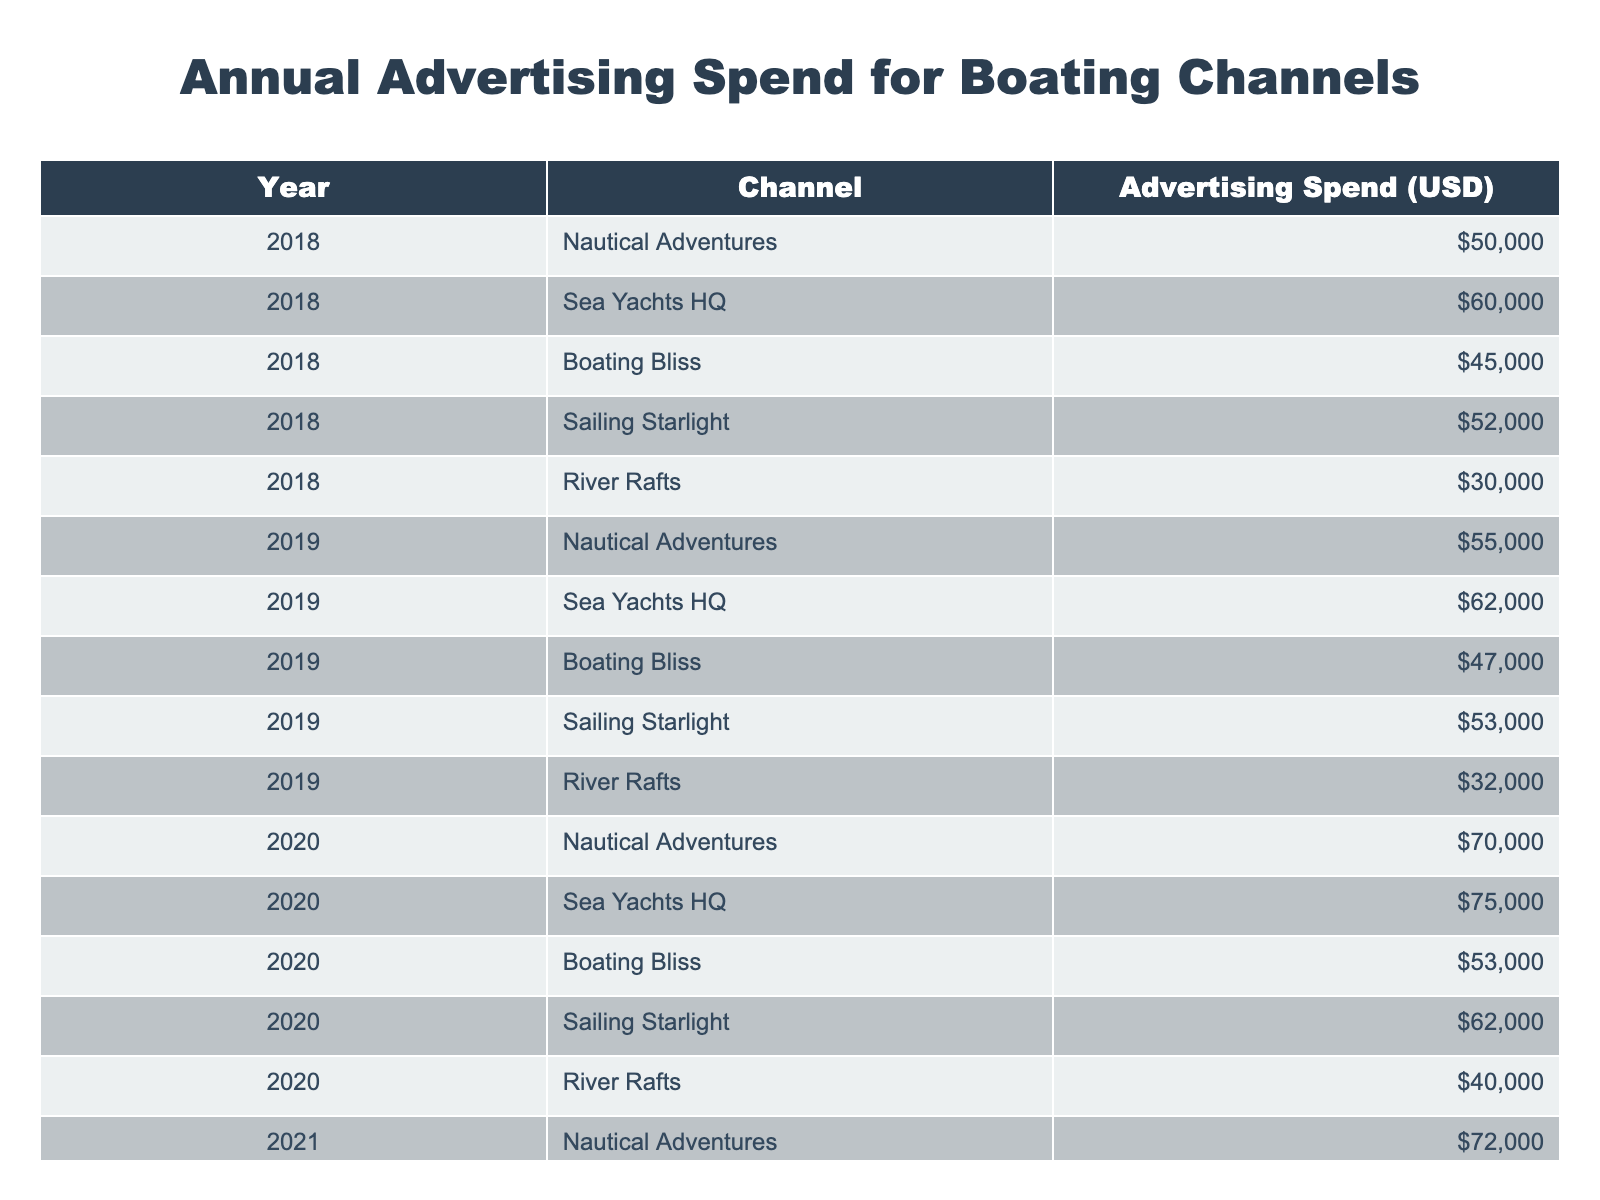What was the highest advertising spend in 2022? In 2022, the highest advertising spend was from Sea Yachts HQ, which amounted to 80,000 USD. This can be determined by comparing the values in the "Advertising Spend (USD)" column for the year 2022.
Answer: 80,000 USD What is the total advertising spend for Nautical Adventures from 2018 to 2022? By adding the advertising spends for Nautical Adventures for each year: 50,000 (2018) + 55,000 (2019) + 70,000 (2020) + 72,000 (2021) + 76,000 (2022) = 323,000 USD. The total is obtained by summing these values.
Answer: 323,000 USD Did the advertising spend for Boating Bliss increase every year from 2018 to 2022? Checking the values for Boating Bliss reveals the following annual spends: 45,000 (2018), 47,000 (2019), 53,000 (2020), 54,000 (2021), and 56,000 (2022). There was an increase from 2018 to 2019 and again to 2020, but there was only a slight increase followed by very little growth in subsequent years, indicating it did not increase every year.
Answer: No What was the average advertising spend for River Rafts over the five years? To find the average for River Rafts, we first sum the advertising spends: 30,000 (2018) + 32,000 (2019) + 40,000 (2020) + 41,000 (2021) + 42,000 (2022) = 185,000 USD. There are five years represented, so we divide the total by 5: 185,000 / 5 = 37,000 USD.
Answer: 37,000 USD Which channel experienced the largest increase in advertising spend from 2021 to 2022? For each channel, we compare the spends between 2021 and 2022. Nautical Adventures went from 72,000 to 76,000 (4,000 increase), Sea Yachts HQ from 76,000 to 80,000 (4,000 increase), Boating Bliss from 54,000 to 56,000 (2,000 increase), Sailing Starlight from 63,000 to 65,000 (2,000 increase), and River Rafts from 41,000 to 42,000 (1,000 increase). Sea Yachts HQ and Nautical Adventures had the largest increase of 4,000 USD.
Answer: Sea Yachts HQ and Nautical Adventures Was there a notable growth trend in advertising spend for Sea Yachts HQ from 2018 to 2022? Examining the annual spending for Sea Yachts HQ yields: 60,000 (2018), 62,000 (2019), 75,000 (2020), 76,000 (2021), and 80,000 (2022). Each year shows an increase from the previous one, indicating a consistent upward trend over the five years.
Answer: Yes 